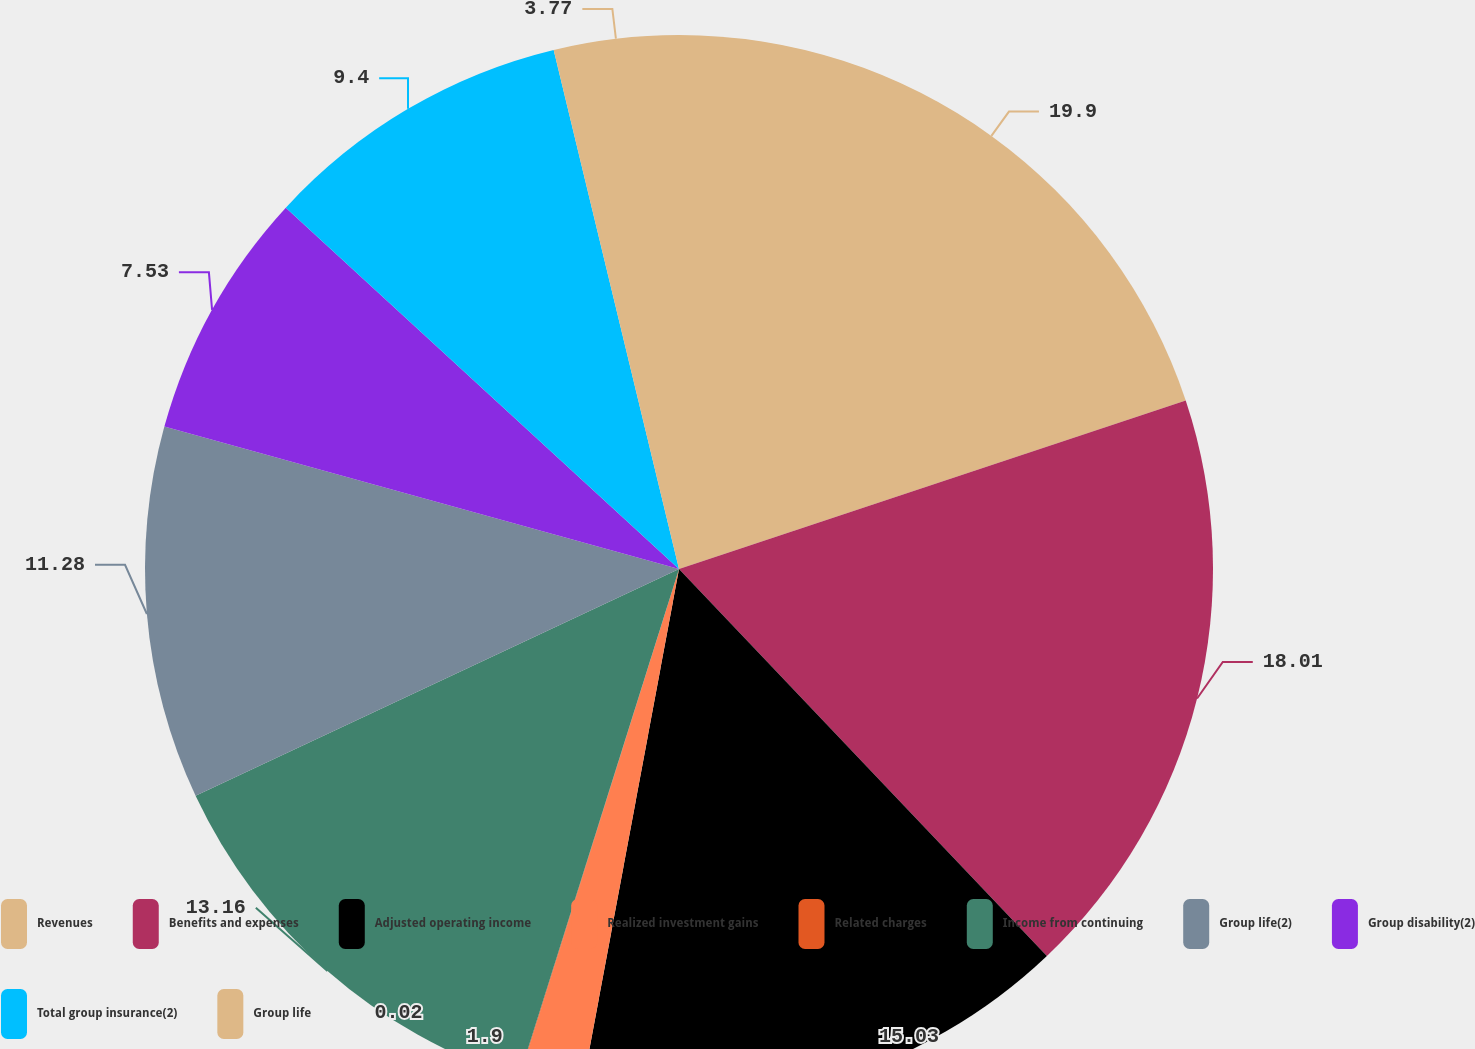Convert chart to OTSL. <chart><loc_0><loc_0><loc_500><loc_500><pie_chart><fcel>Revenues<fcel>Benefits and expenses<fcel>Adjusted operating income<fcel>Realized investment gains<fcel>Related charges<fcel>Income from continuing<fcel>Group life(2)<fcel>Group disability(2)<fcel>Total group insurance(2)<fcel>Group life<nl><fcel>19.89%<fcel>18.01%<fcel>15.03%<fcel>1.9%<fcel>0.02%<fcel>13.16%<fcel>11.28%<fcel>7.53%<fcel>9.4%<fcel>3.77%<nl></chart> 